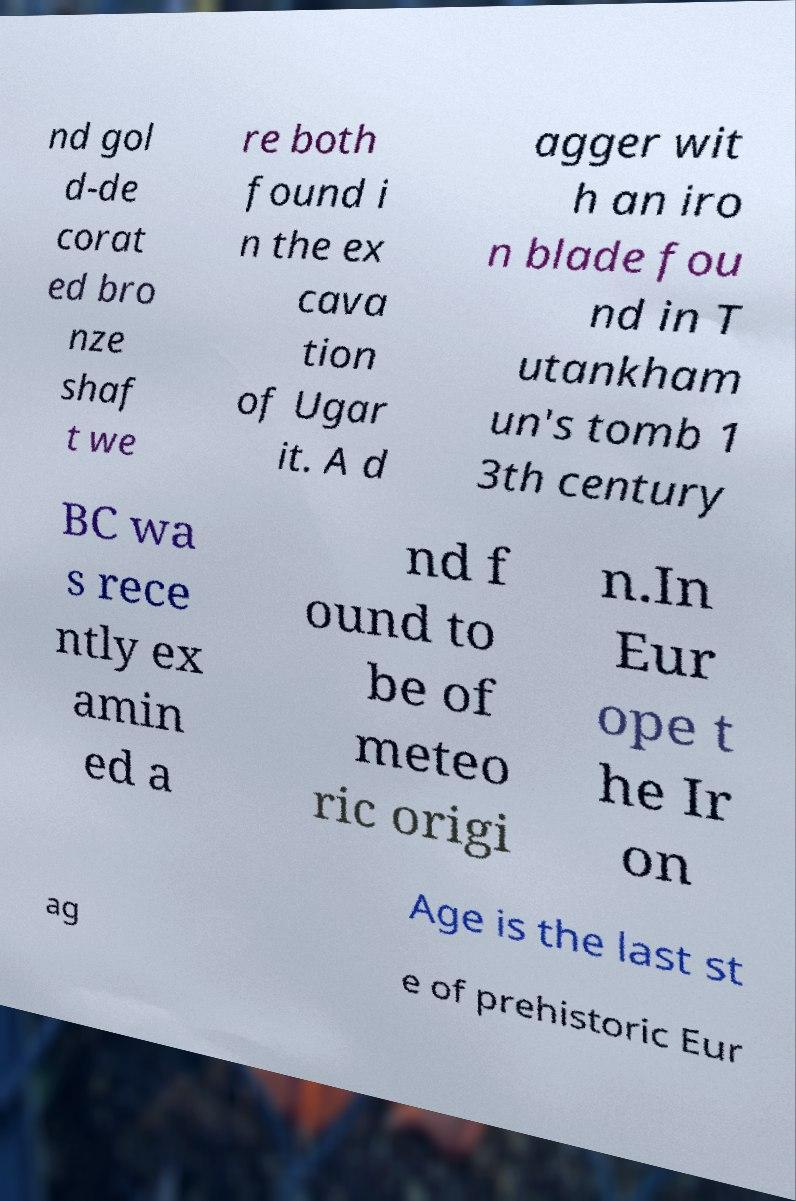What messages or text are displayed in this image? I need them in a readable, typed format. nd gol d-de corat ed bro nze shaf t we re both found i n the ex cava tion of Ugar it. A d agger wit h an iro n blade fou nd in T utankham un's tomb 1 3th century BC wa s rece ntly ex amin ed a nd f ound to be of meteo ric origi n.In Eur ope t he Ir on Age is the last st ag e of prehistoric Eur 